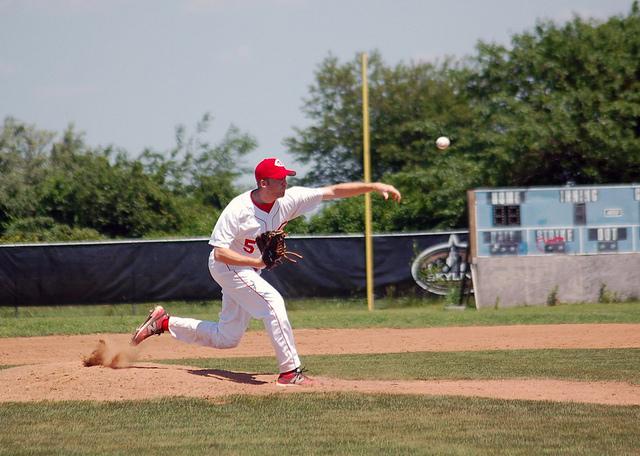What type of ball is the man throwing?
Give a very brief answer. Baseball. Is this a smaller league baseball stadium?
Answer briefly. Yes. What sport is this?
Concise answer only. Baseball. 